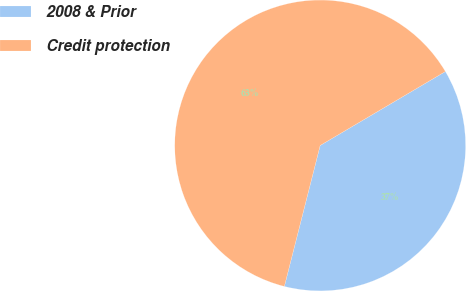Convert chart. <chart><loc_0><loc_0><loc_500><loc_500><pie_chart><fcel>2008 & Prior<fcel>Credit protection<nl><fcel>37.45%<fcel>62.55%<nl></chart> 